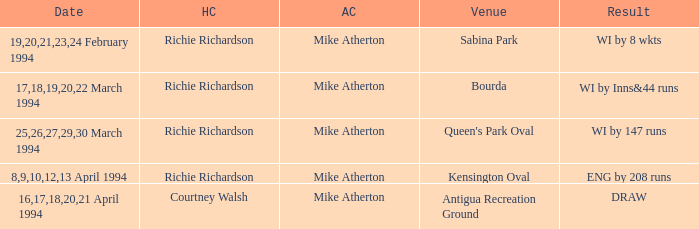When did a Venue of Antigua Recreation Ground happen? 16,17,18,20,21 April 1994. 